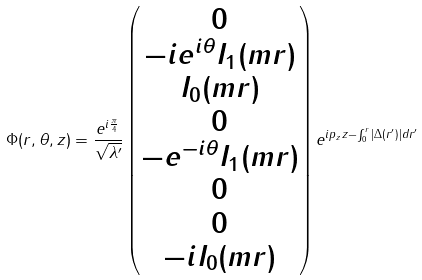Convert formula to latex. <formula><loc_0><loc_0><loc_500><loc_500>\Phi ( r , \theta , z ) = \frac { e ^ { i \frac { \pi } { 4 } } } { \sqrt { \lambda ^ { \prime } } } \begin{pmatrix} 0 \\ - i e ^ { i \theta } I _ { 1 } ( m r ) \\ I _ { 0 } ( m r ) \\ 0 \\ - e ^ { - i \theta } I _ { 1 } ( m r ) \\ 0 \\ 0 \\ - i I _ { 0 } ( m r ) \end{pmatrix} e ^ { i p _ { z } z - \int _ { 0 } ^ { r } | \Delta ( r ^ { \prime } ) | d r ^ { \prime } }</formula> 